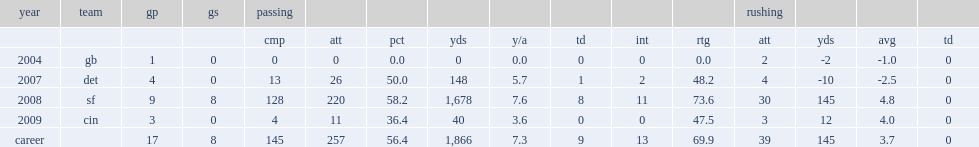How many interceptions did o'sullivan get in 2007? 2.0. 